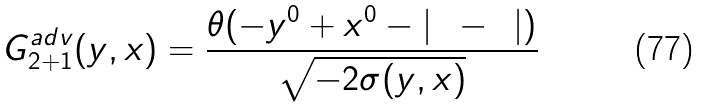Convert formula to latex. <formula><loc_0><loc_0><loc_500><loc_500>G _ { 2 + 1 } ^ { a d v } ( y , x ) = \frac { \theta ( - y ^ { 0 } + x ^ { 0 } - | { \mathbf y } - { \mathbf x } | ) } { \sqrt { - 2 \sigma ( y , x ) } }</formula> 